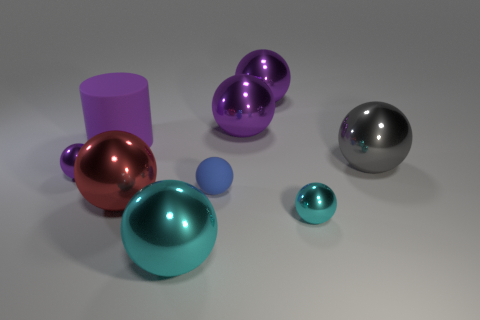Are there any other things that have the same size as the blue thing?
Provide a succinct answer. Yes. How many metallic objects have the same color as the cylinder?
Provide a succinct answer. 3. What number of things are large spheres that are behind the small purple sphere or rubber things?
Your response must be concise. 5. Is there a large red thing of the same shape as the blue thing?
Ensure brevity in your answer.  Yes. The small shiny object in front of the purple metal sphere that is in front of the big cylinder is what shape?
Your answer should be compact. Sphere. What number of cubes are large cyan rubber things or purple things?
Your answer should be very brief. 0. What material is the tiny ball that is the same color as the big rubber cylinder?
Make the answer very short. Metal. There is a small thing that is in front of the small matte object; is it the same shape as the large purple object that is to the left of the large red sphere?
Offer a terse response. No. What is the color of the big metal ball that is both right of the tiny rubber sphere and in front of the purple matte thing?
Your answer should be compact. Gray. There is a rubber cylinder; is it the same color as the matte thing in front of the small purple metallic object?
Provide a short and direct response. No. 